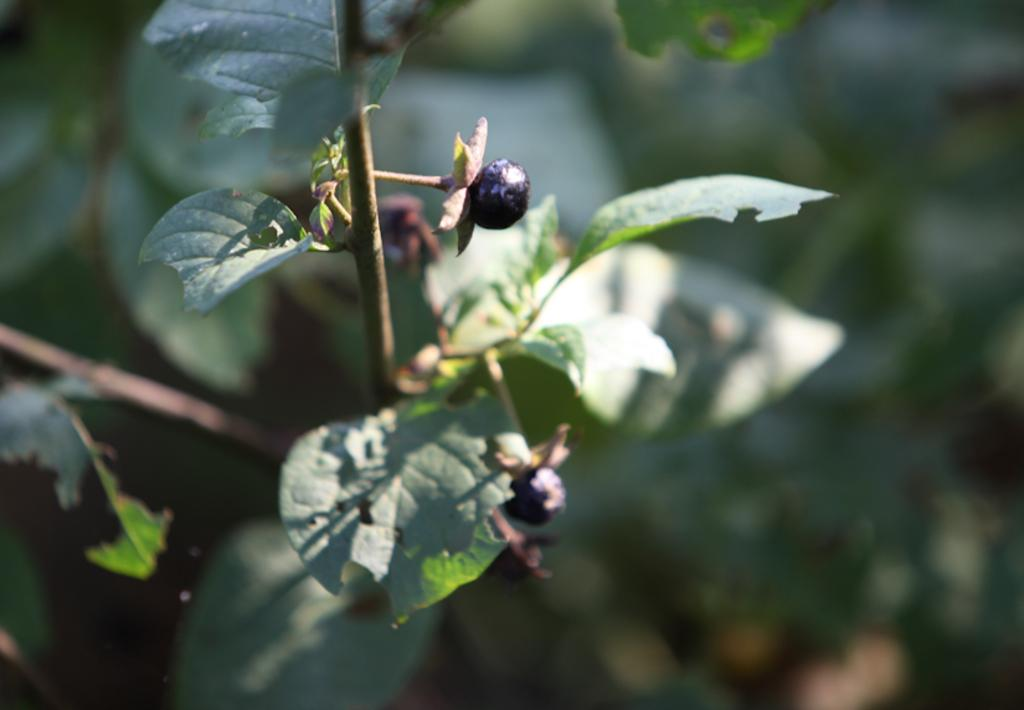What type of vegetation can be seen in the image? There are leaves in the image. What is attached to the leaves in the image? Blueberries are attached to the leaves in the image. What does the dad say about the rail in the image? There is no dad or rail present in the image, so this question cannot be answered. 